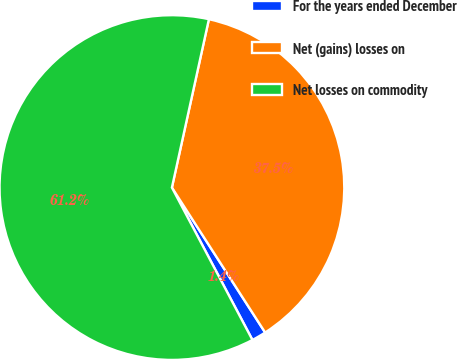Convert chart to OTSL. <chart><loc_0><loc_0><loc_500><loc_500><pie_chart><fcel>For the years ended December<fcel>Net (gains) losses on<fcel>Net losses on commodity<nl><fcel>1.36%<fcel>37.46%<fcel>61.18%<nl></chart> 